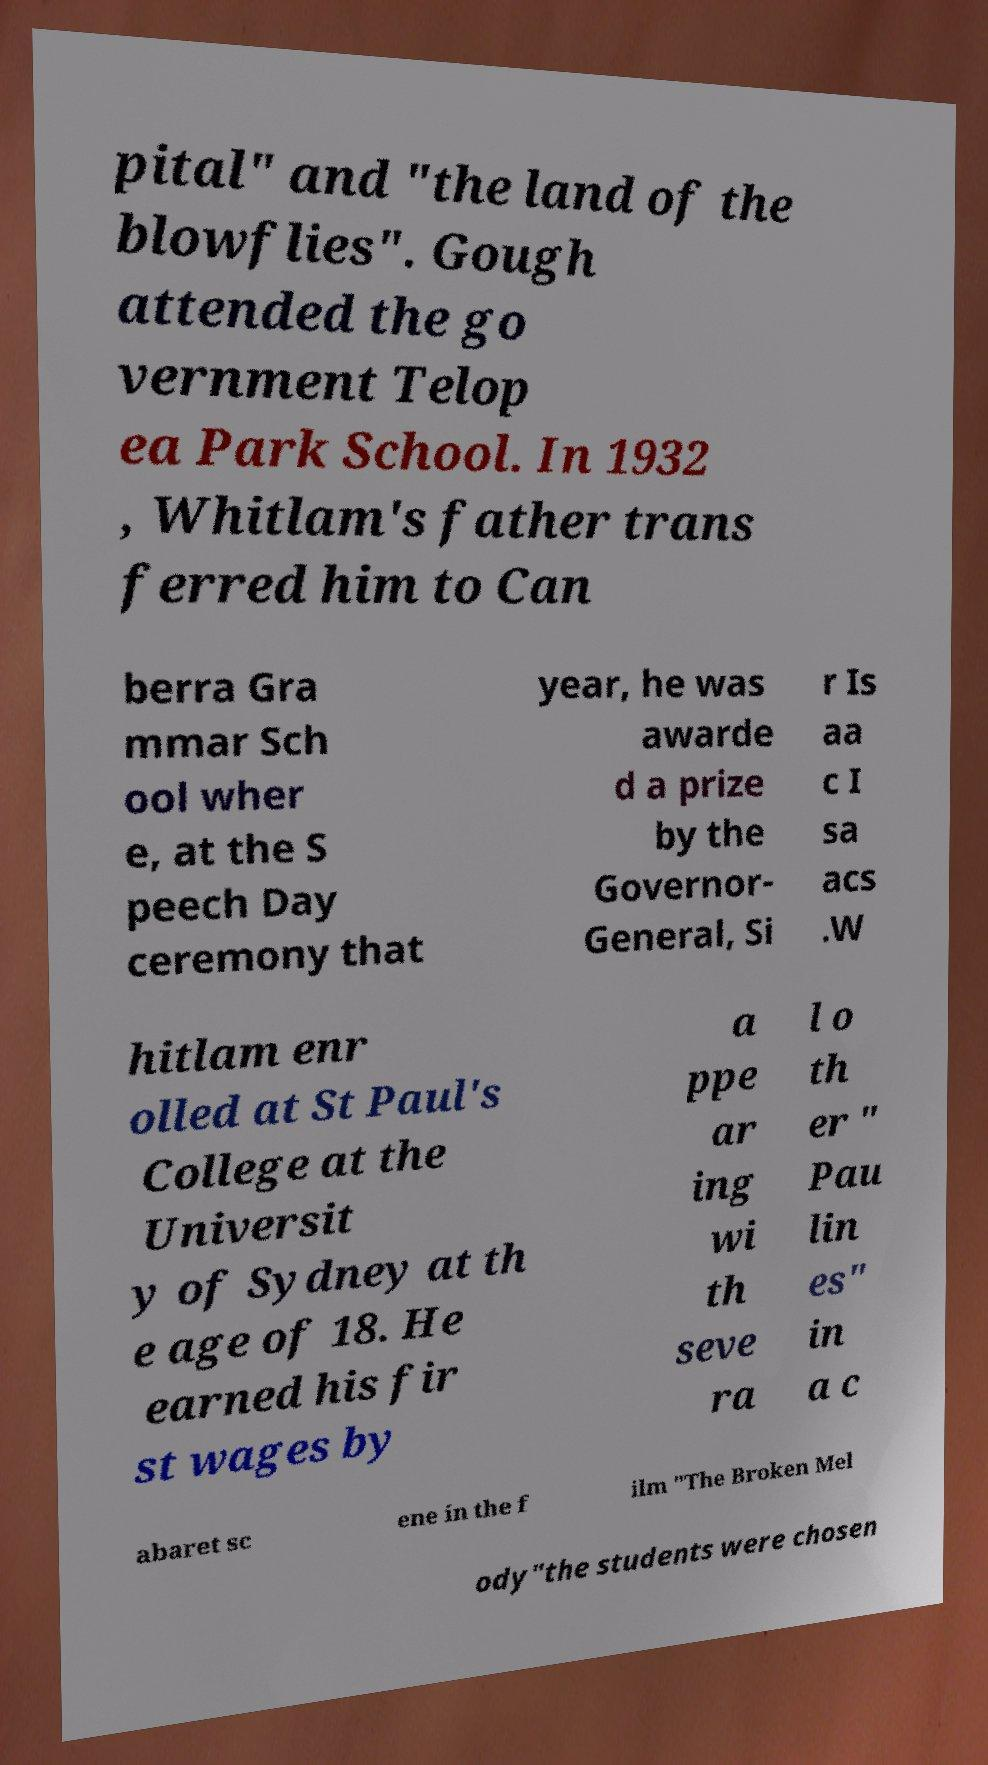There's text embedded in this image that I need extracted. Can you transcribe it verbatim? pital" and "the land of the blowflies". Gough attended the go vernment Telop ea Park School. In 1932 , Whitlam's father trans ferred him to Can berra Gra mmar Sch ool wher e, at the S peech Day ceremony that year, he was awarde d a prize by the Governor- General, Si r Is aa c I sa acs .W hitlam enr olled at St Paul's College at the Universit y of Sydney at th e age of 18. He earned his fir st wages by a ppe ar ing wi th seve ra l o th er " Pau lin es" in a c abaret sc ene in the f ilm "The Broken Mel ody"the students were chosen 